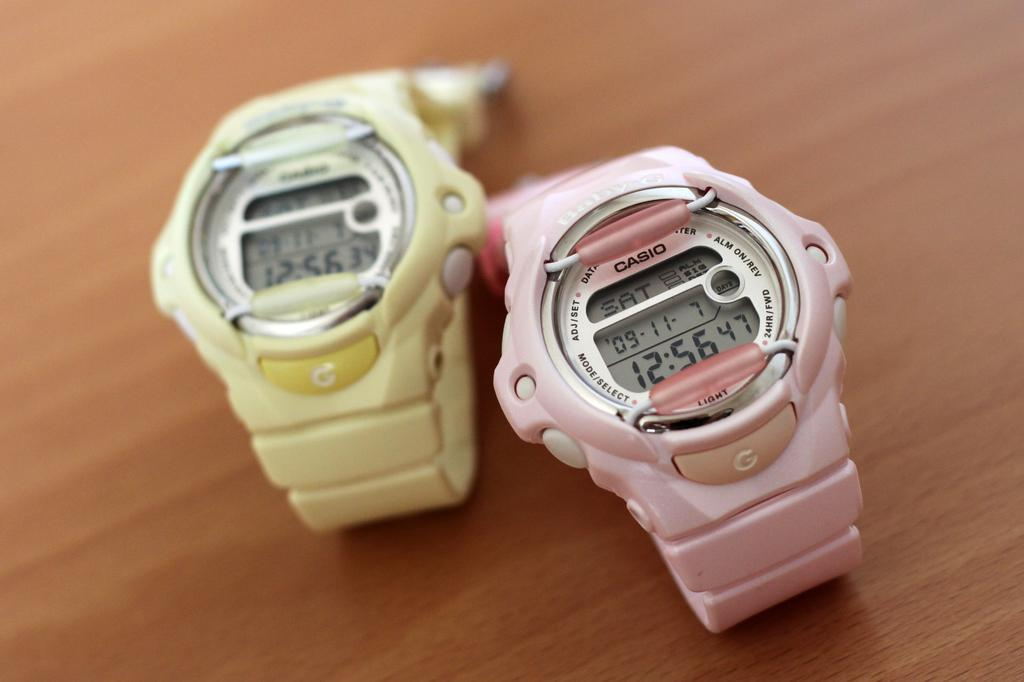<image>
Describe the image concisely. Two watches, one pink, one yellow, displaying SAT 09-11- 7 12:56, with settings around the face for MODE/SELECT, LIGHT, ADJ/SET and others. 